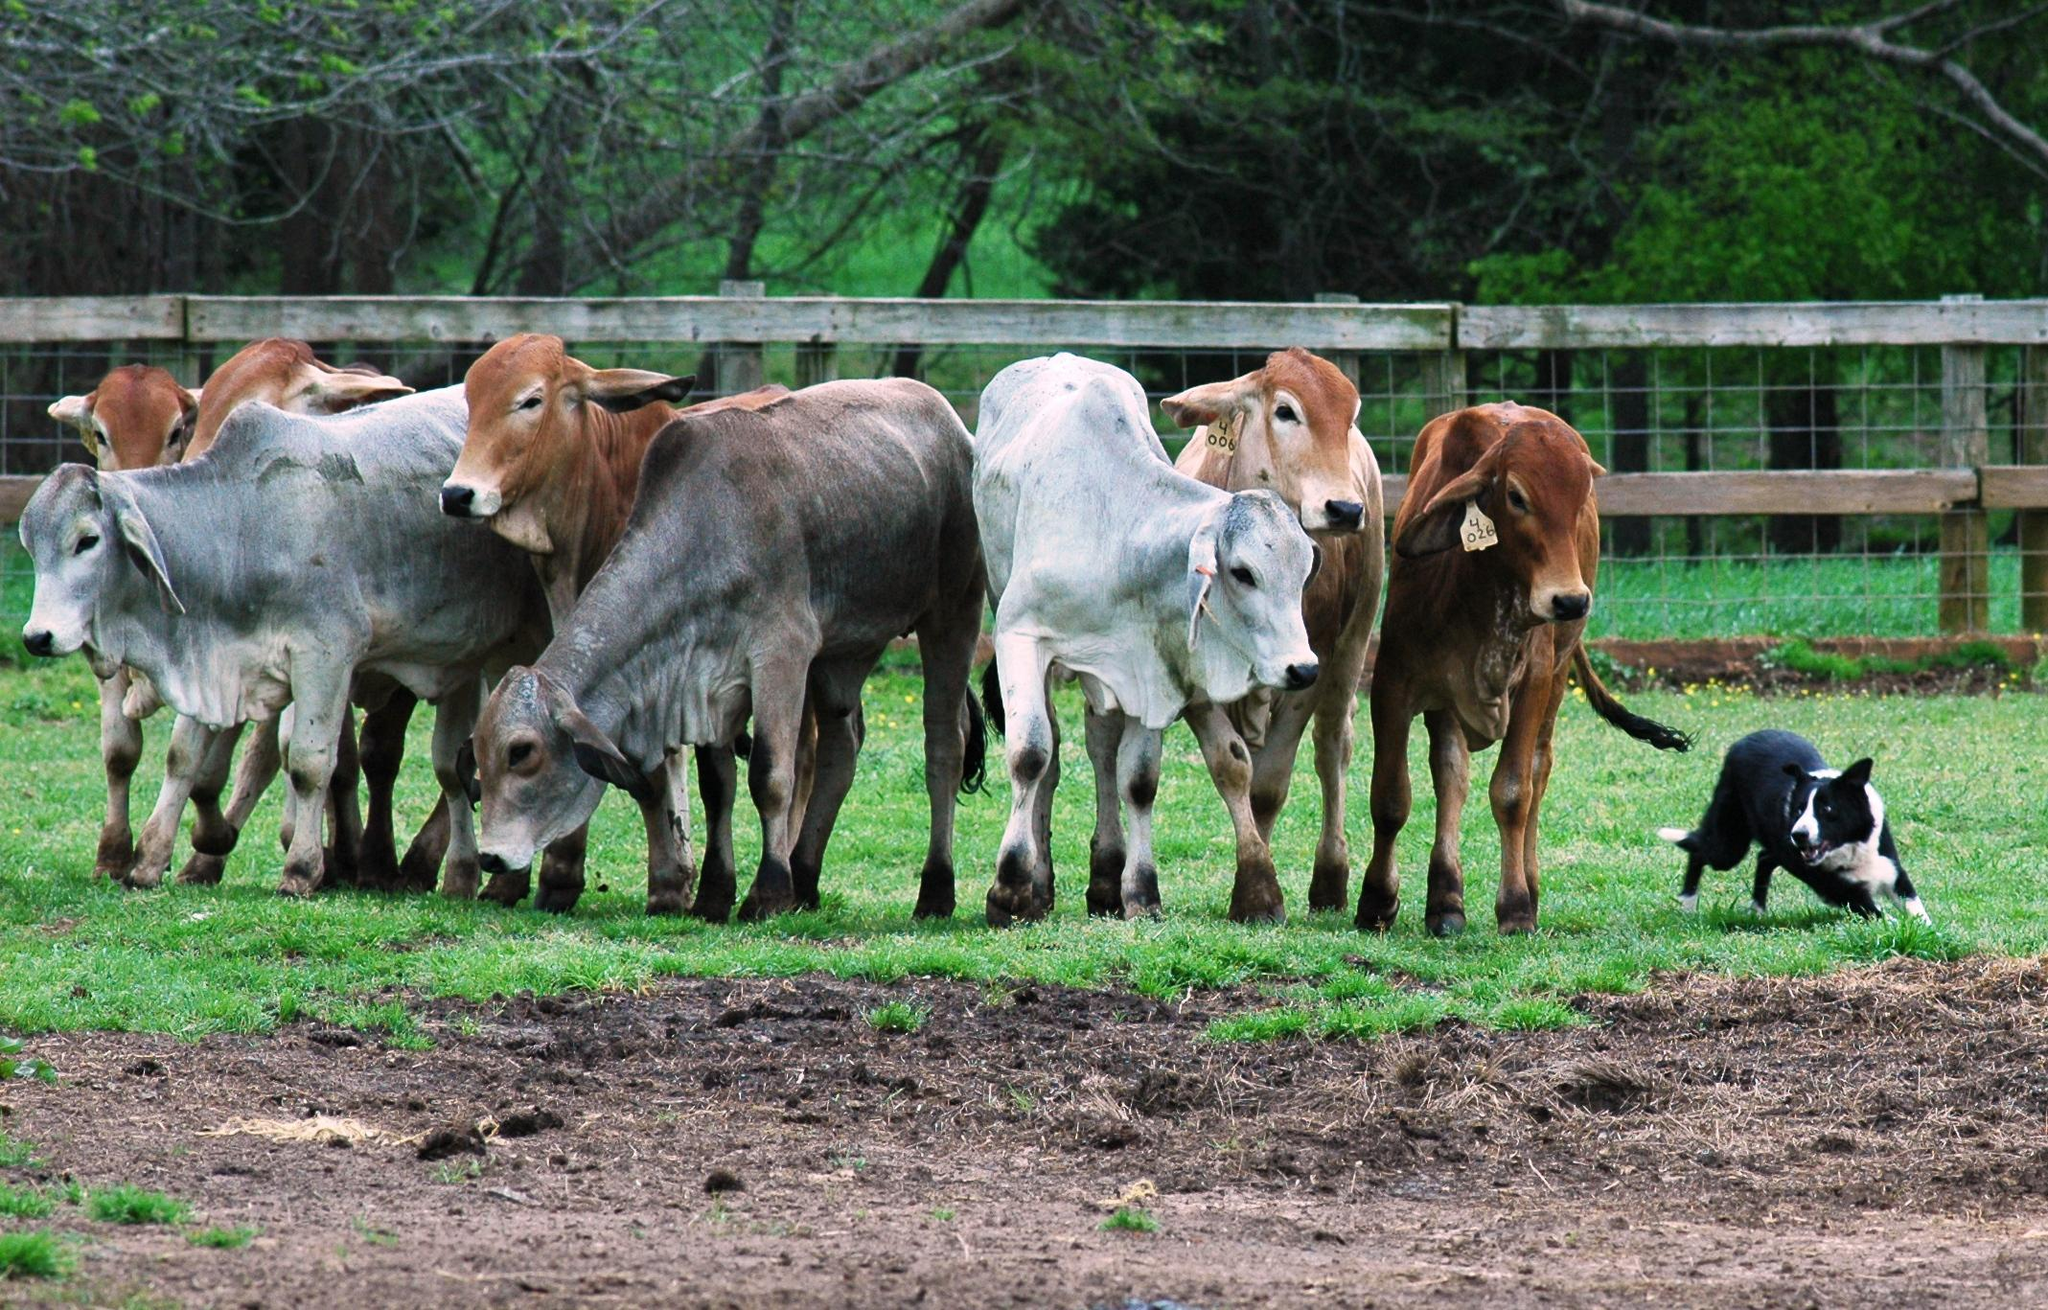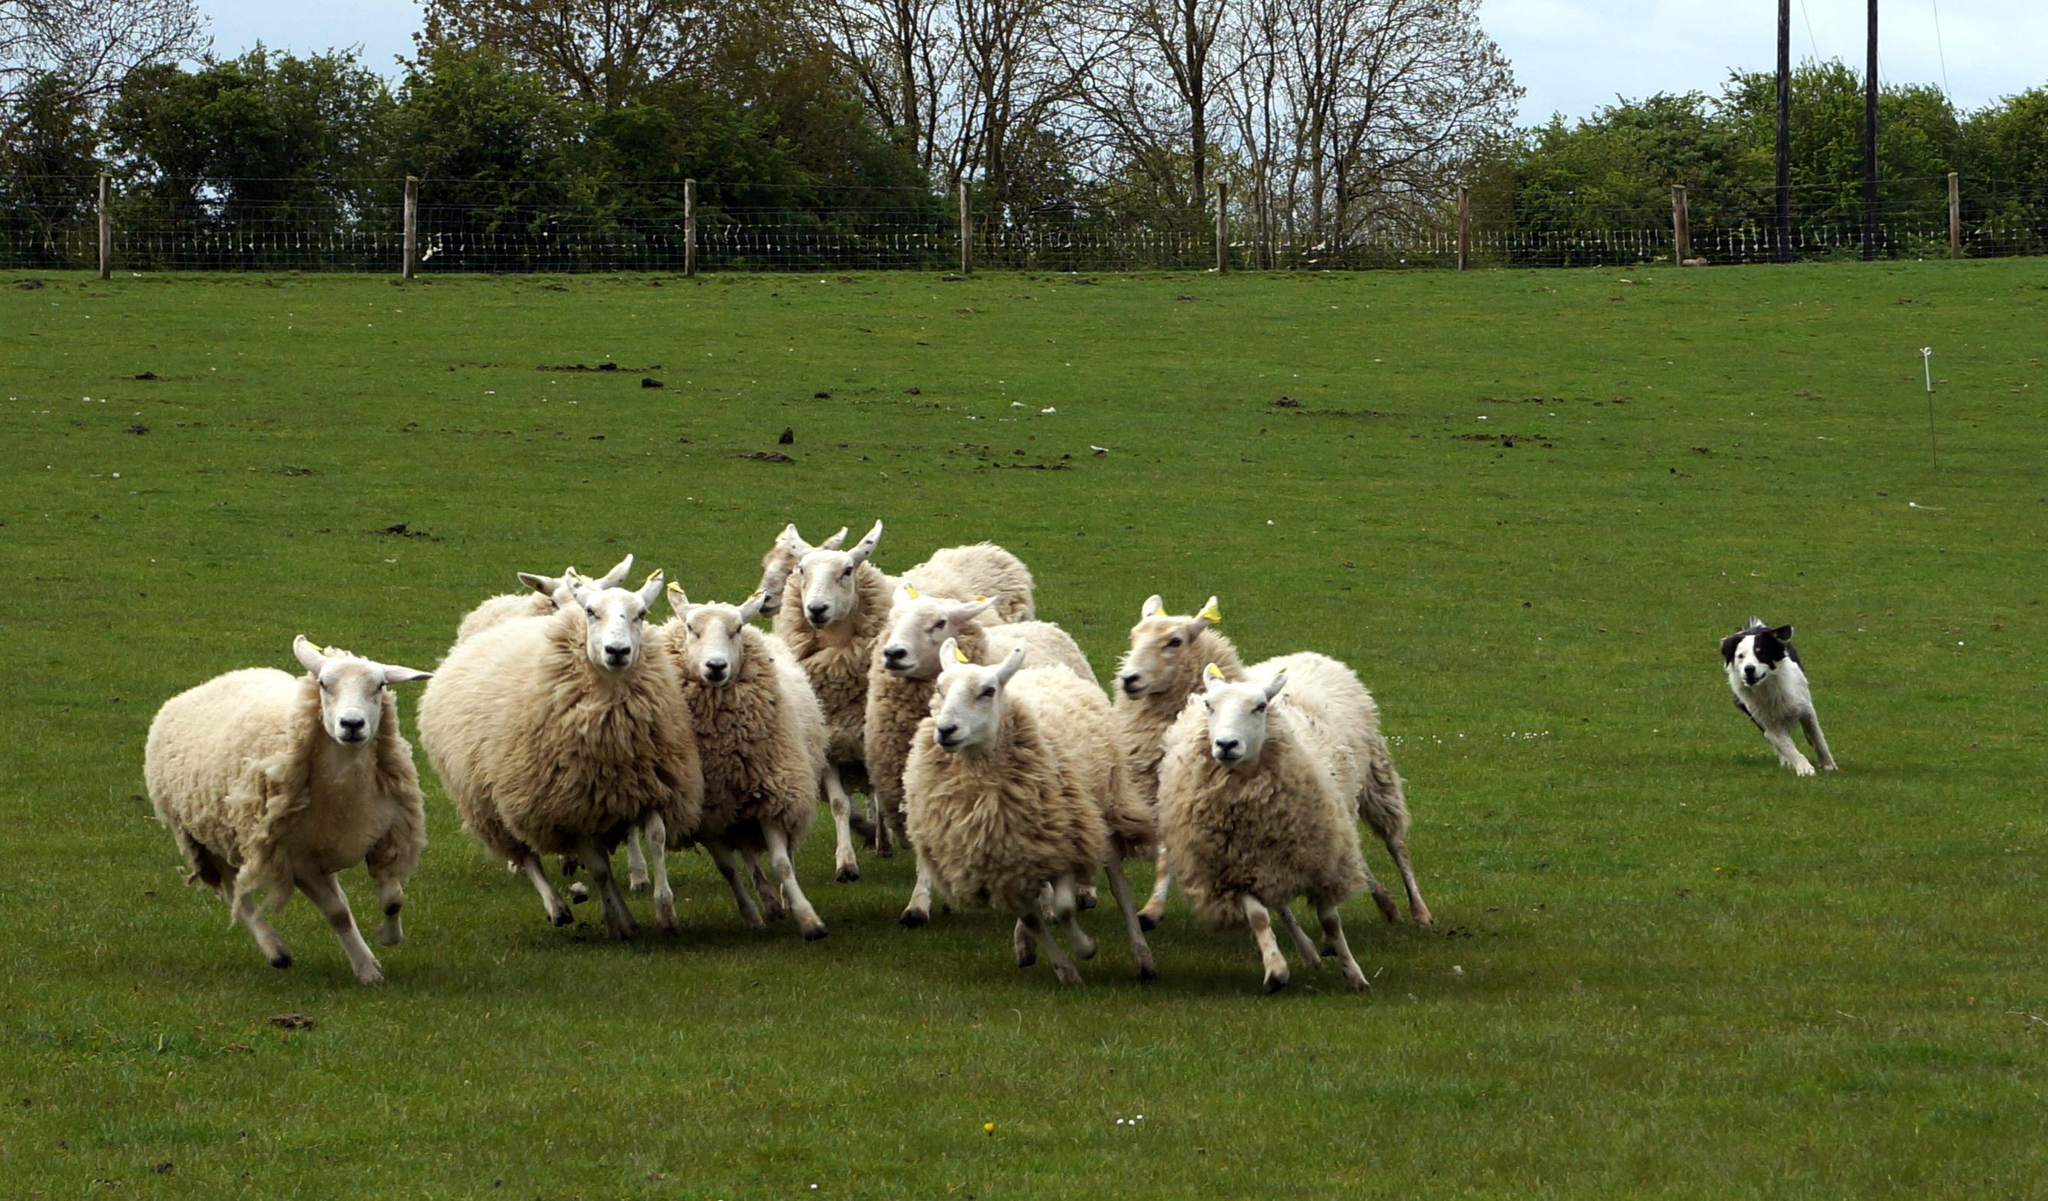The first image is the image on the left, the second image is the image on the right. Examine the images to the left and right. Is the description "Some of the animals are near a wooden fence." accurate? Answer yes or no. Yes. The first image is the image on the left, the second image is the image on the right. Assess this claim about the two images: "The right photo contains exactly three sheep.". Correct or not? Answer yes or no. No. 